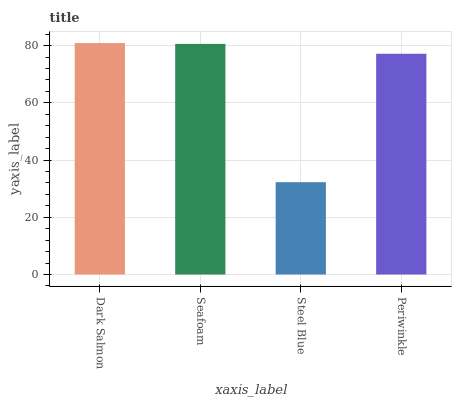Is Steel Blue the minimum?
Answer yes or no. Yes. Is Dark Salmon the maximum?
Answer yes or no. Yes. Is Seafoam the minimum?
Answer yes or no. No. Is Seafoam the maximum?
Answer yes or no. No. Is Dark Salmon greater than Seafoam?
Answer yes or no. Yes. Is Seafoam less than Dark Salmon?
Answer yes or no. Yes. Is Seafoam greater than Dark Salmon?
Answer yes or no. No. Is Dark Salmon less than Seafoam?
Answer yes or no. No. Is Seafoam the high median?
Answer yes or no. Yes. Is Periwinkle the low median?
Answer yes or no. Yes. Is Periwinkle the high median?
Answer yes or no. No. Is Steel Blue the low median?
Answer yes or no. No. 